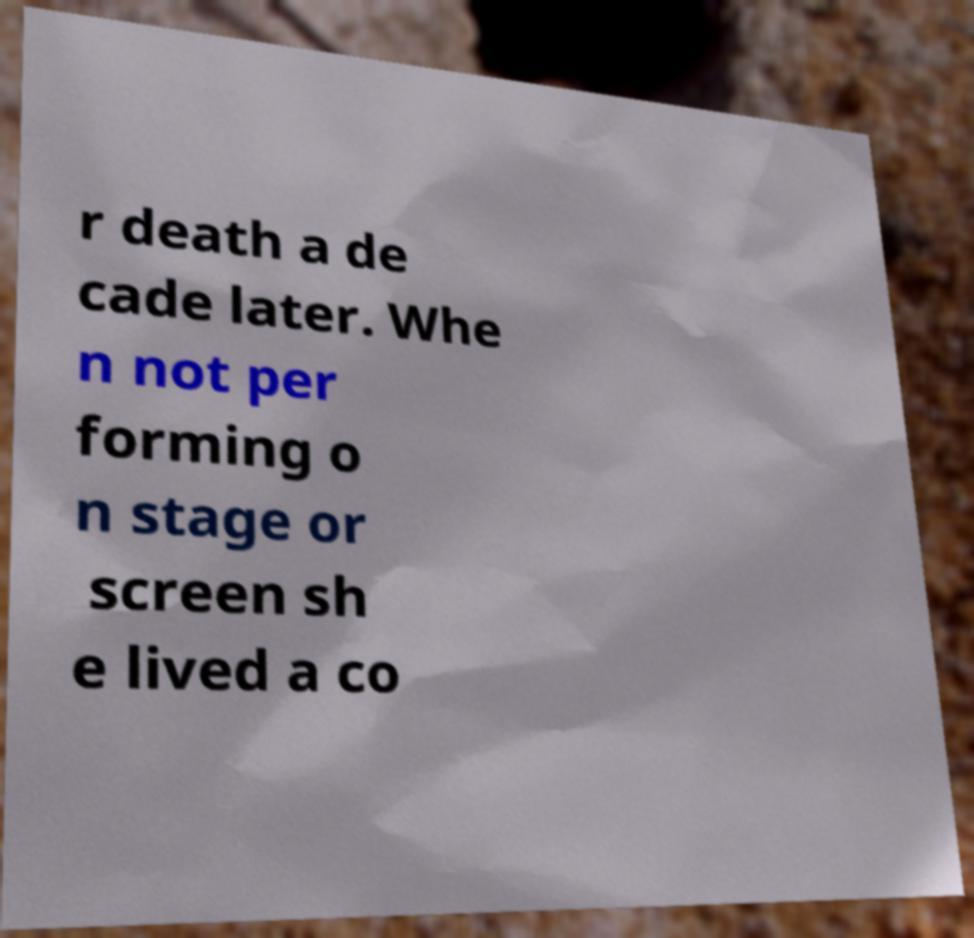Could you assist in decoding the text presented in this image and type it out clearly? r death a de cade later. Whe n not per forming o n stage or screen sh e lived a co 